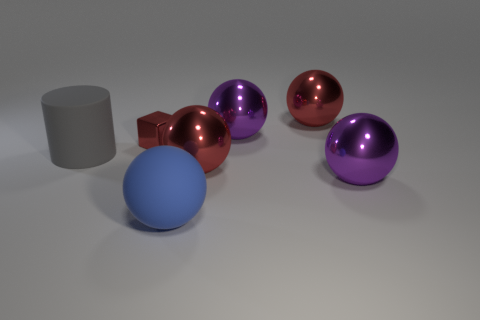Imagine this image is part of a puzzle, what piece would you say is missing in this setup? If we were to perceive this assemblage as a puzzle, one might say it is missing a geometric piece that could complete a certain sequence or balance. Perhaps a pyramid or another angular form could add both visual interest and implied symmetry to the composition, thereby 'completing' the scene in a conceptual sense. 